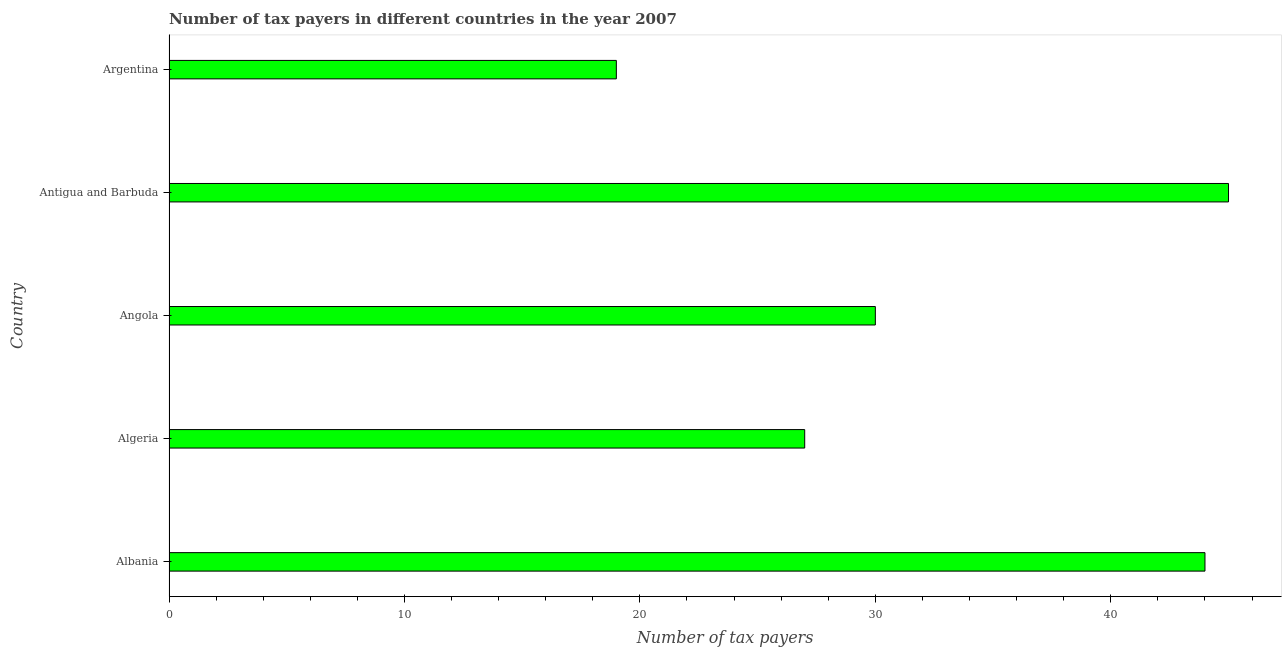Does the graph contain grids?
Your answer should be compact. No. What is the title of the graph?
Your response must be concise. Number of tax payers in different countries in the year 2007. What is the label or title of the X-axis?
Your answer should be very brief. Number of tax payers. Across all countries, what is the maximum number of tax payers?
Make the answer very short. 45. Across all countries, what is the minimum number of tax payers?
Make the answer very short. 19. In which country was the number of tax payers maximum?
Your answer should be compact. Antigua and Barbuda. In which country was the number of tax payers minimum?
Offer a terse response. Argentina. What is the sum of the number of tax payers?
Your answer should be very brief. 165. What is the ratio of the number of tax payers in Albania to that in Angola?
Ensure brevity in your answer.  1.47. Is the number of tax payers in Algeria less than that in Argentina?
Give a very brief answer. No. Is the difference between the number of tax payers in Algeria and Argentina greater than the difference between any two countries?
Your answer should be compact. No. How many bars are there?
Provide a short and direct response. 5. Are all the bars in the graph horizontal?
Offer a very short reply. Yes. How many countries are there in the graph?
Keep it short and to the point. 5. Are the values on the major ticks of X-axis written in scientific E-notation?
Make the answer very short. No. What is the Number of tax payers of Albania?
Your response must be concise. 44. What is the Number of tax payers in Angola?
Your answer should be compact. 30. What is the Number of tax payers in Argentina?
Your answer should be very brief. 19. What is the difference between the Number of tax payers in Albania and Angola?
Make the answer very short. 14. What is the difference between the Number of tax payers in Albania and Antigua and Barbuda?
Give a very brief answer. -1. What is the difference between the Number of tax payers in Algeria and Angola?
Provide a short and direct response. -3. What is the difference between the Number of tax payers in Algeria and Argentina?
Offer a very short reply. 8. What is the difference between the Number of tax payers in Angola and Antigua and Barbuda?
Your answer should be compact. -15. What is the difference between the Number of tax payers in Angola and Argentina?
Ensure brevity in your answer.  11. What is the ratio of the Number of tax payers in Albania to that in Algeria?
Provide a succinct answer. 1.63. What is the ratio of the Number of tax payers in Albania to that in Angola?
Ensure brevity in your answer.  1.47. What is the ratio of the Number of tax payers in Albania to that in Argentina?
Make the answer very short. 2.32. What is the ratio of the Number of tax payers in Algeria to that in Angola?
Provide a short and direct response. 0.9. What is the ratio of the Number of tax payers in Algeria to that in Antigua and Barbuda?
Offer a terse response. 0.6. What is the ratio of the Number of tax payers in Algeria to that in Argentina?
Give a very brief answer. 1.42. What is the ratio of the Number of tax payers in Angola to that in Antigua and Barbuda?
Ensure brevity in your answer.  0.67. What is the ratio of the Number of tax payers in Angola to that in Argentina?
Keep it short and to the point. 1.58. What is the ratio of the Number of tax payers in Antigua and Barbuda to that in Argentina?
Your answer should be very brief. 2.37. 